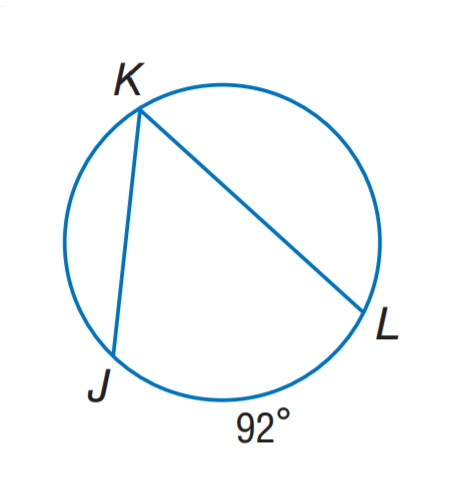Answer the mathemtical geometry problem and directly provide the correct option letter.
Question: Find m \angle K.
Choices: A: 46 B: 63 C: 69 D: 92 A 